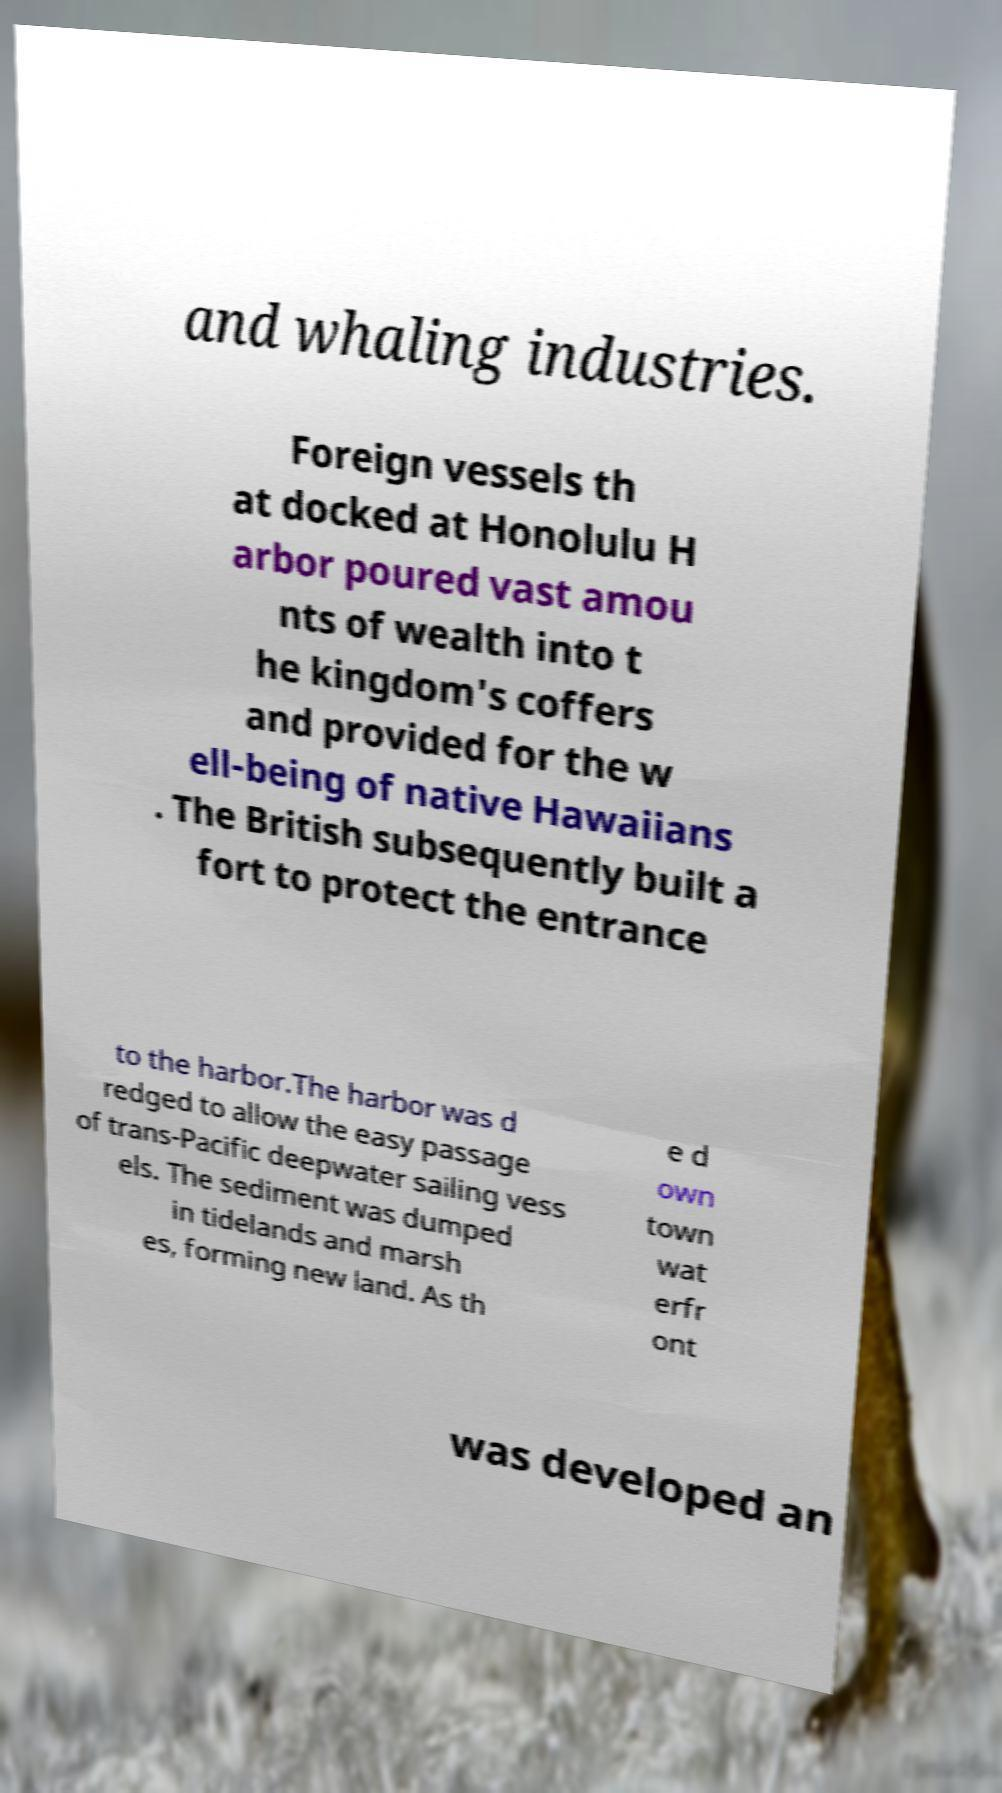Please read and relay the text visible in this image. What does it say? and whaling industries. Foreign vessels th at docked at Honolulu H arbor poured vast amou nts of wealth into t he kingdom's coffers and provided for the w ell-being of native Hawaiians . The British subsequently built a fort to protect the entrance to the harbor.The harbor was d redged to allow the easy passage of trans-Pacific deepwater sailing vess els. The sediment was dumped in tidelands and marsh es, forming new land. As th e d own town wat erfr ont was developed an 